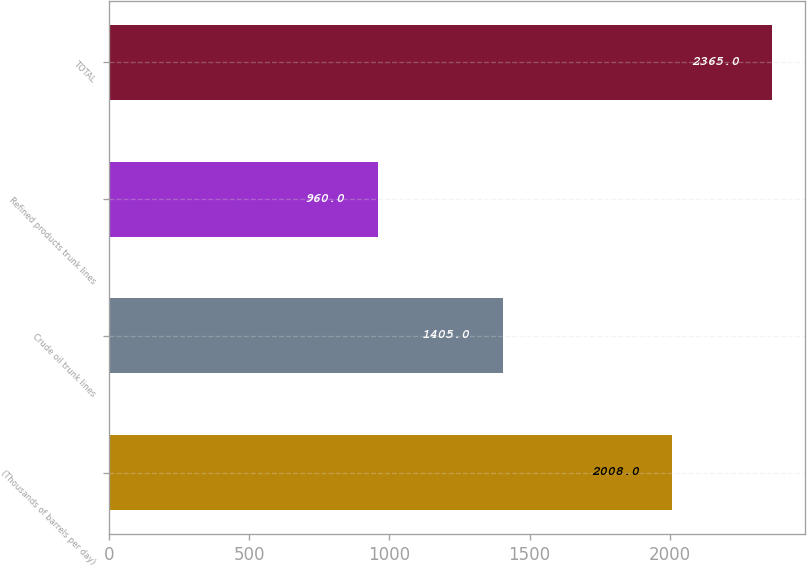Convert chart to OTSL. <chart><loc_0><loc_0><loc_500><loc_500><bar_chart><fcel>(Thousands of barrels per day)<fcel>Crude oil trunk lines<fcel>Refined products trunk lines<fcel>TOTAL<nl><fcel>2008<fcel>1405<fcel>960<fcel>2365<nl></chart> 